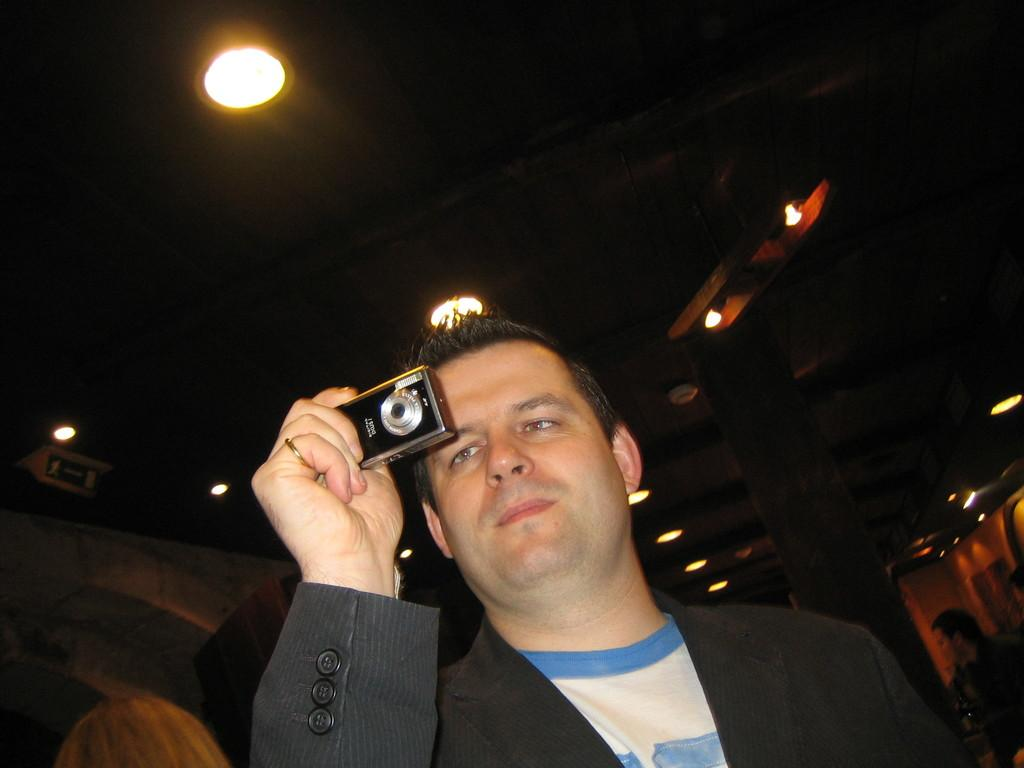What is the main subject of the image? There is a man standing in the middle of the image. What is the man holding in the image? The man is holding a camera. What can be seen at the top of the image? There is a roof and light visible at the top of the image. How many chairs are visible in the image? There are no chairs present in the image. What type of error can be seen in the image? There is no error visible in the image. 